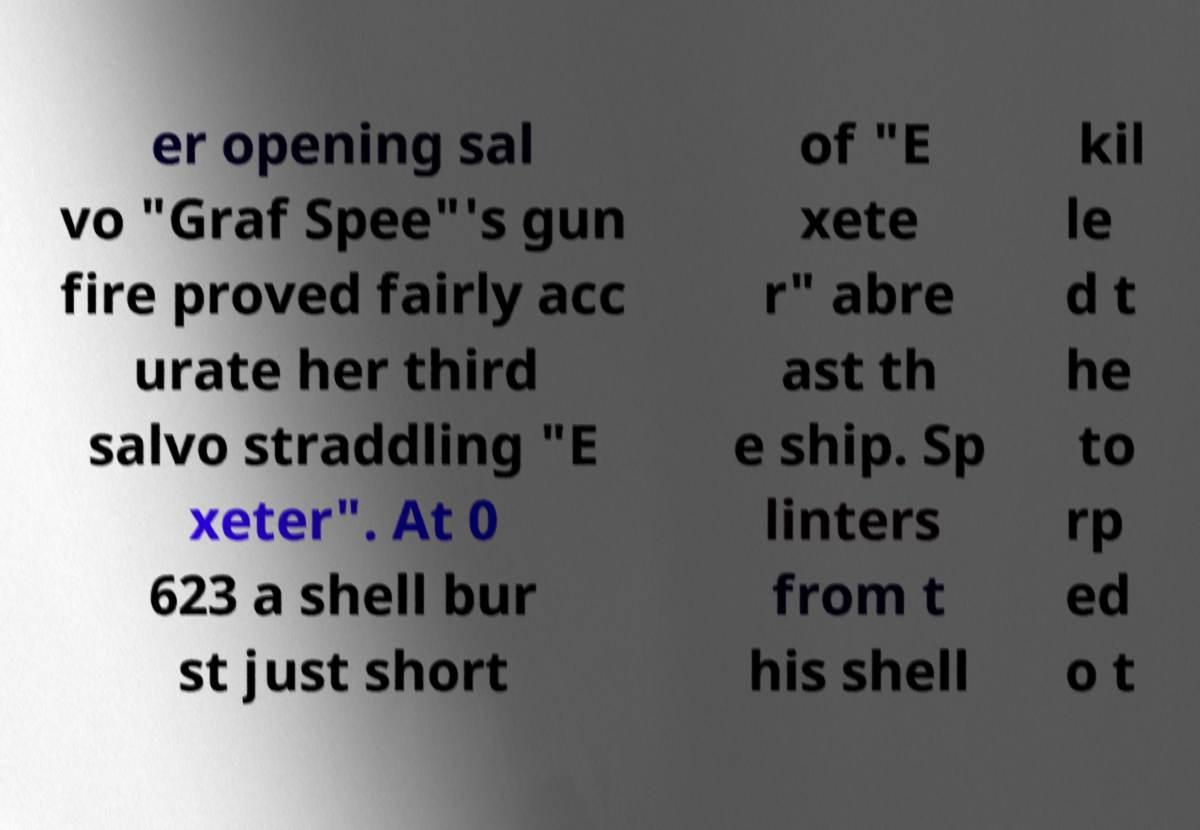Please read and relay the text visible in this image. What does it say? er opening sal vo "Graf Spee"'s gun fire proved fairly acc urate her third salvo straddling "E xeter". At 0 623 a shell bur st just short of "E xete r" abre ast th e ship. Sp linters from t his shell kil le d t he to rp ed o t 